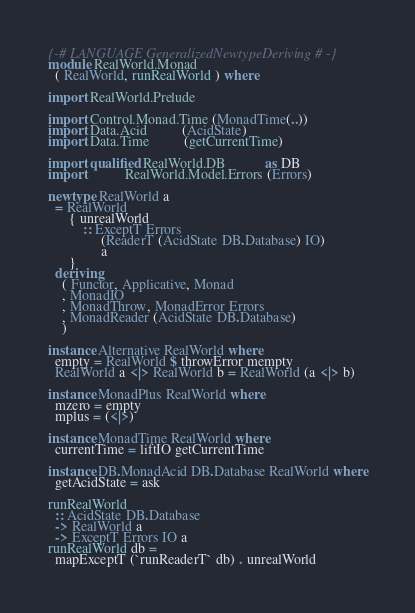Convert code to text. <code><loc_0><loc_0><loc_500><loc_500><_Haskell_>{-# LANGUAGE GeneralizedNewtypeDeriving #-}
module RealWorld.Monad
  ( RealWorld, runRealWorld ) where

import RealWorld.Prelude

import Control.Monad.Time (MonadTime(..))
import Data.Acid          (AcidState)
import Data.Time          (getCurrentTime)

import qualified RealWorld.DB           as DB
import           RealWorld.Model.Errors (Errors)

newtype RealWorld a
  = RealWorld
      { unrealWorld
          :: ExceptT Errors
               (ReaderT (AcidState DB.Database) IO)
               a
      }
  deriving
    ( Functor, Applicative, Monad
    , MonadIO
    , MonadThrow, MonadError Errors
    , MonadReader (AcidState DB.Database)
    )

instance Alternative RealWorld where
  empty = RealWorld $ throwError mempty
  RealWorld a <|> RealWorld b = RealWorld (a <|> b)

instance MonadPlus RealWorld where
  mzero = empty
  mplus = (<|>)

instance MonadTime RealWorld where
  currentTime = liftIO getCurrentTime

instance DB.MonadAcid DB.Database RealWorld where
  getAcidState = ask

runRealWorld
  :: AcidState DB.Database
  -> RealWorld a
  -> ExceptT Errors IO a
runRealWorld db =
  mapExceptT (`runReaderT` db) . unrealWorld
</code> 